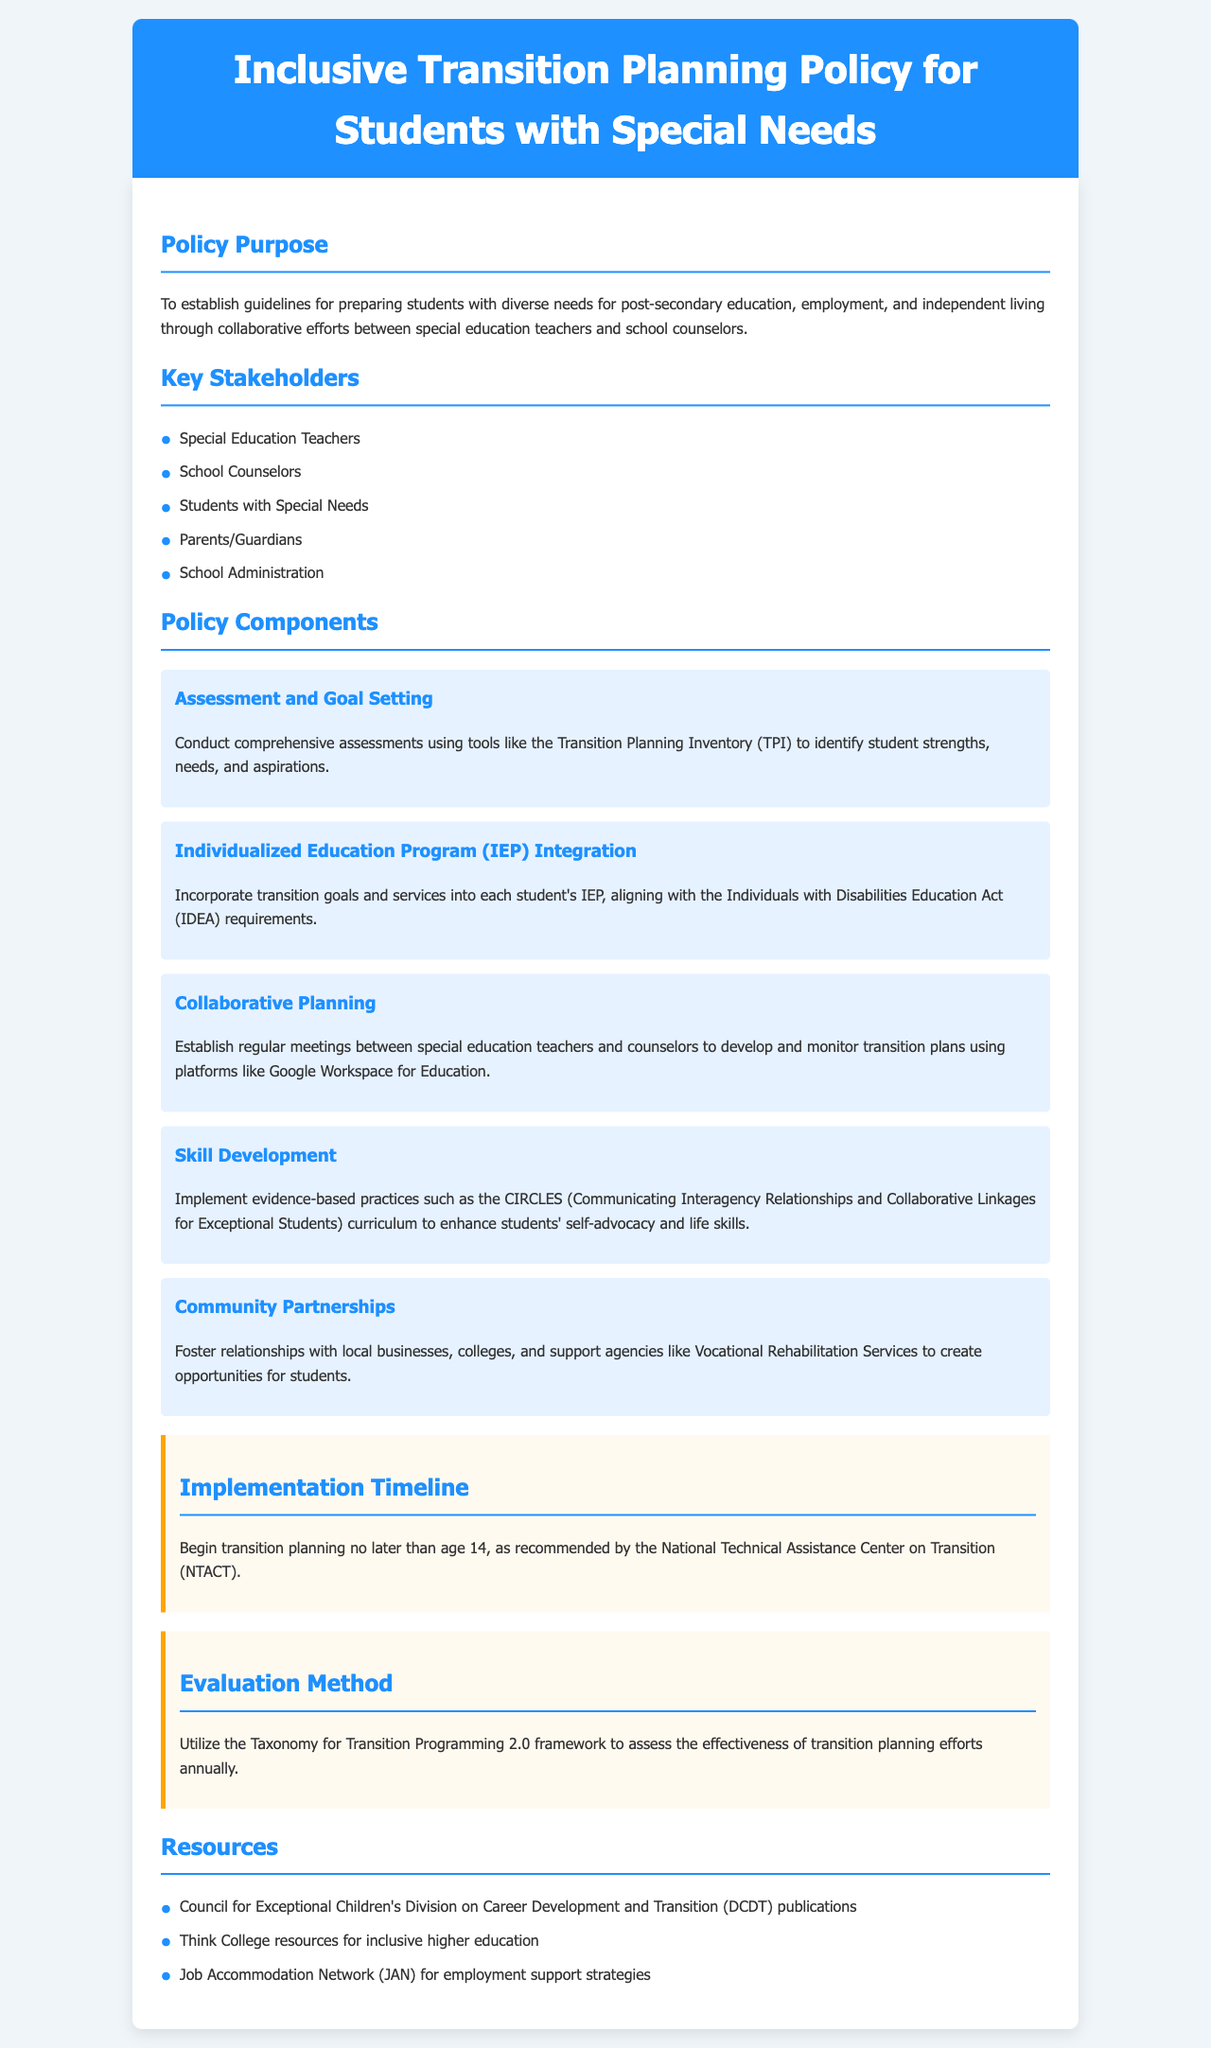What is the purpose of the policy? The purpose of the policy is to establish guidelines for preparing students with diverse needs for post-secondary education, employment, and independent living.
Answer: To establish guidelines for preparing students with diverse needs for post-secondary education, employment, and independent living Who are the key stakeholders mentioned? The document lists specific groups involved in the transition planning process as key stakeholders.
Answer: Special Education Teachers, School Counselors, Students with Special Needs, Parents/Guardians, School Administration What assessment tool is recommended for use? The document identifies a specific tool used to assess student strengths and needs as part of the transition planning process.
Answer: Transition Planning Inventory (TPI) At what age should transition planning begin? The policy specifies a recommended age for beginning transition planning, which is important for timely preparations.
Answer: Age 14 What curriculum is mentioned for skill development? The document refers to a specific curriculum designed to enhance self-advocacy and life skills among students.
Answer: CIRCLES (Communicating Interagency Relationships and Collaborative Linkages for Exceptional Students) What framework is used to evaluate the transition planning efforts? The evaluation method mentioned in the policy refers to a particular framework for assessing the effectiveness of transition planning.
Answer: Taxonomy for Transition Programming 2.0 How often should the transition planning efforts be assessed? The document specifies the frequency with which the evaluation of transition planning should occur.
Answer: Annually 